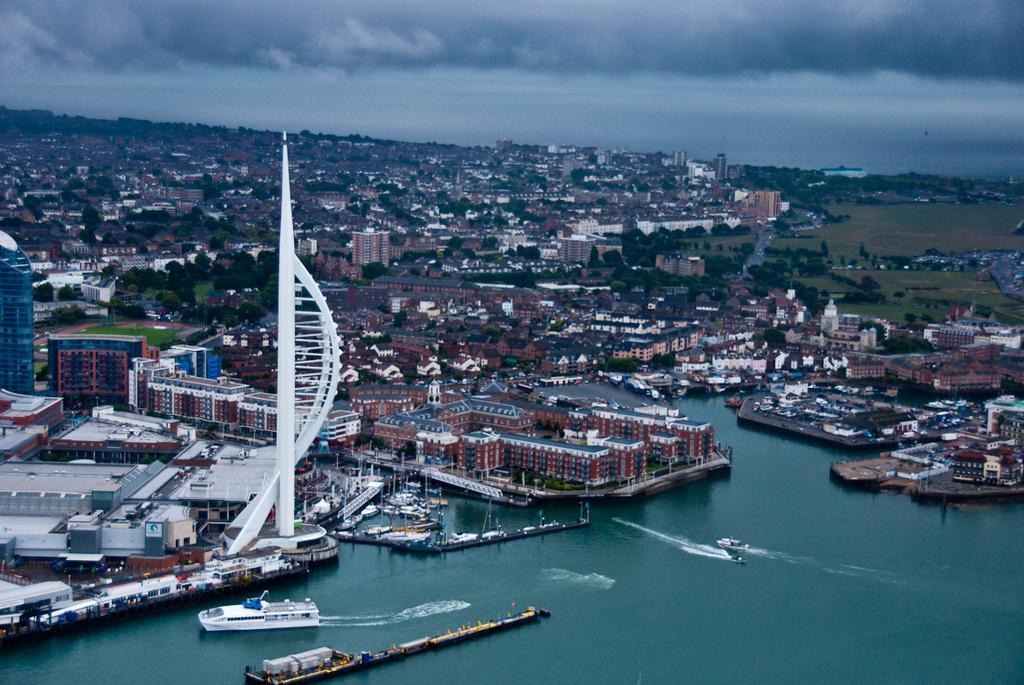Please provide a concise description of this image. In this picture we can see boats on water, buildings, trees and in the background we can see the sky with clouds. 